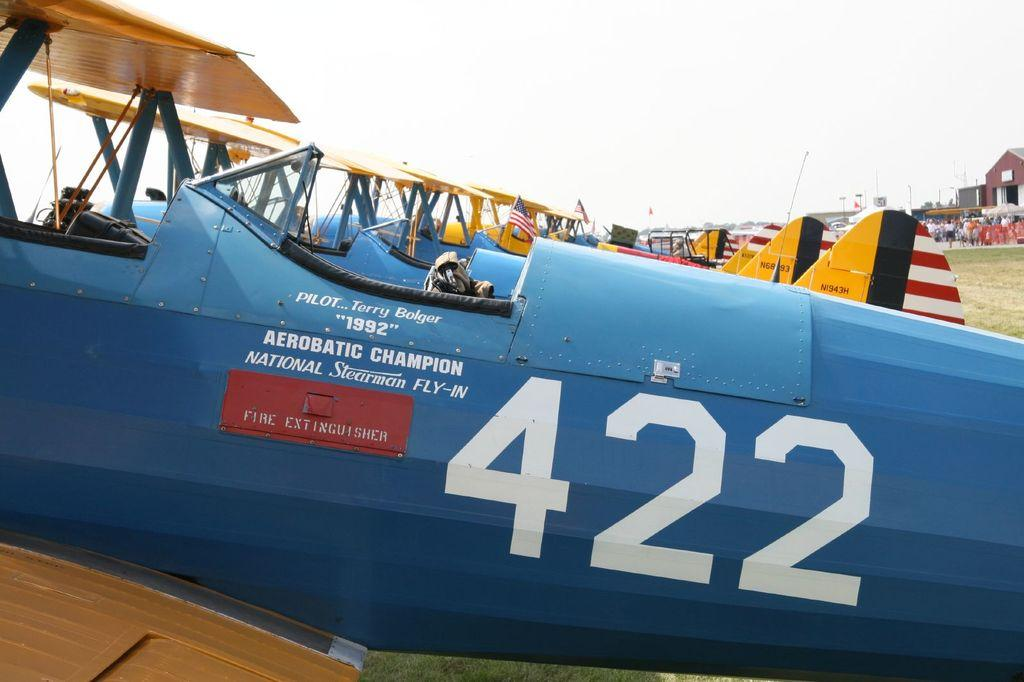<image>
Write a terse but informative summary of the picture. A blue aeroplane fuselage with the number 422 on it 